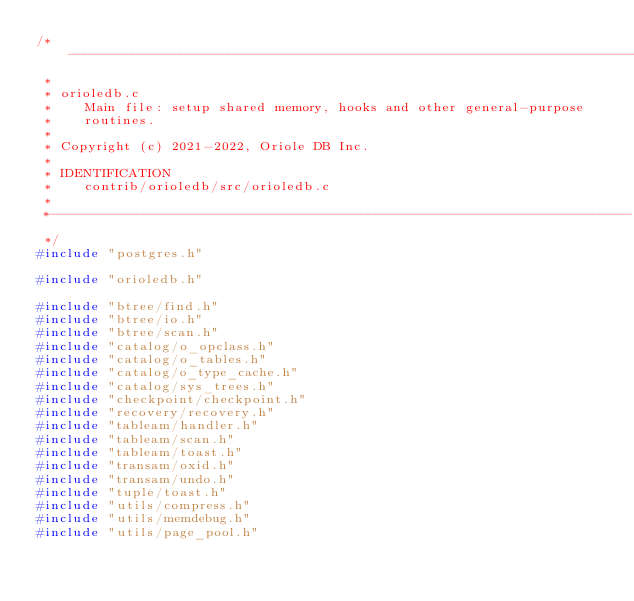Convert code to text. <code><loc_0><loc_0><loc_500><loc_500><_C_>/*-------------------------------------------------------------------------
 *
 * orioledb.c
 *		Main file: setup shared memory, hooks and other general-purpose
 *		routines.
 *
 * Copyright (c) 2021-2022, Oriole DB Inc.
 *
 * IDENTIFICATION
 *	  contrib/orioledb/src/orioledb.c
 *
 *-------------------------------------------------------------------------
 */
#include "postgres.h"

#include "orioledb.h"

#include "btree/find.h"
#include "btree/io.h"
#include "btree/scan.h"
#include "catalog/o_opclass.h"
#include "catalog/o_tables.h"
#include "catalog/o_type_cache.h"
#include "catalog/sys_trees.h"
#include "checkpoint/checkpoint.h"
#include "recovery/recovery.h"
#include "tableam/handler.h"
#include "tableam/scan.h"
#include "tableam/toast.h"
#include "transam/oxid.h"
#include "transam/undo.h"
#include "tuple/toast.h"
#include "utils/compress.h"
#include "utils/memdebug.h"
#include "utils/page_pool.h"</code> 